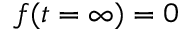Convert formula to latex. <formula><loc_0><loc_0><loc_500><loc_500>f ( t = \infty ) = 0</formula> 